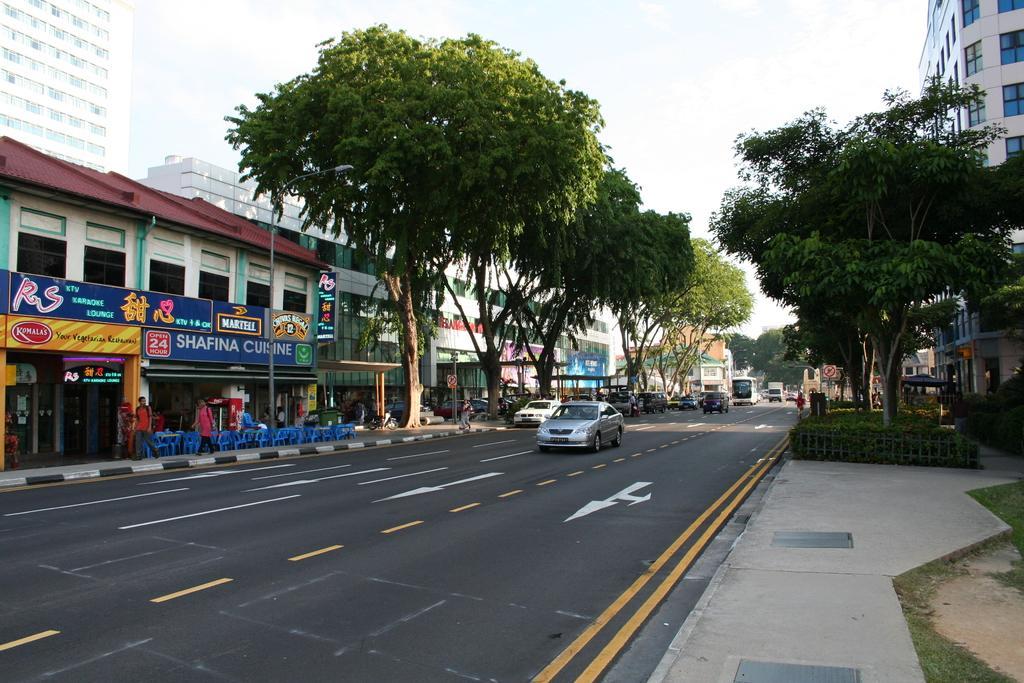Could you give a brief overview of what you see in this image? In this image we can see vehicles moving on the road, fence, trees, people walking on the sidewalk, chairs and tables, banners, boards, buildings and the plain sky in the background. 